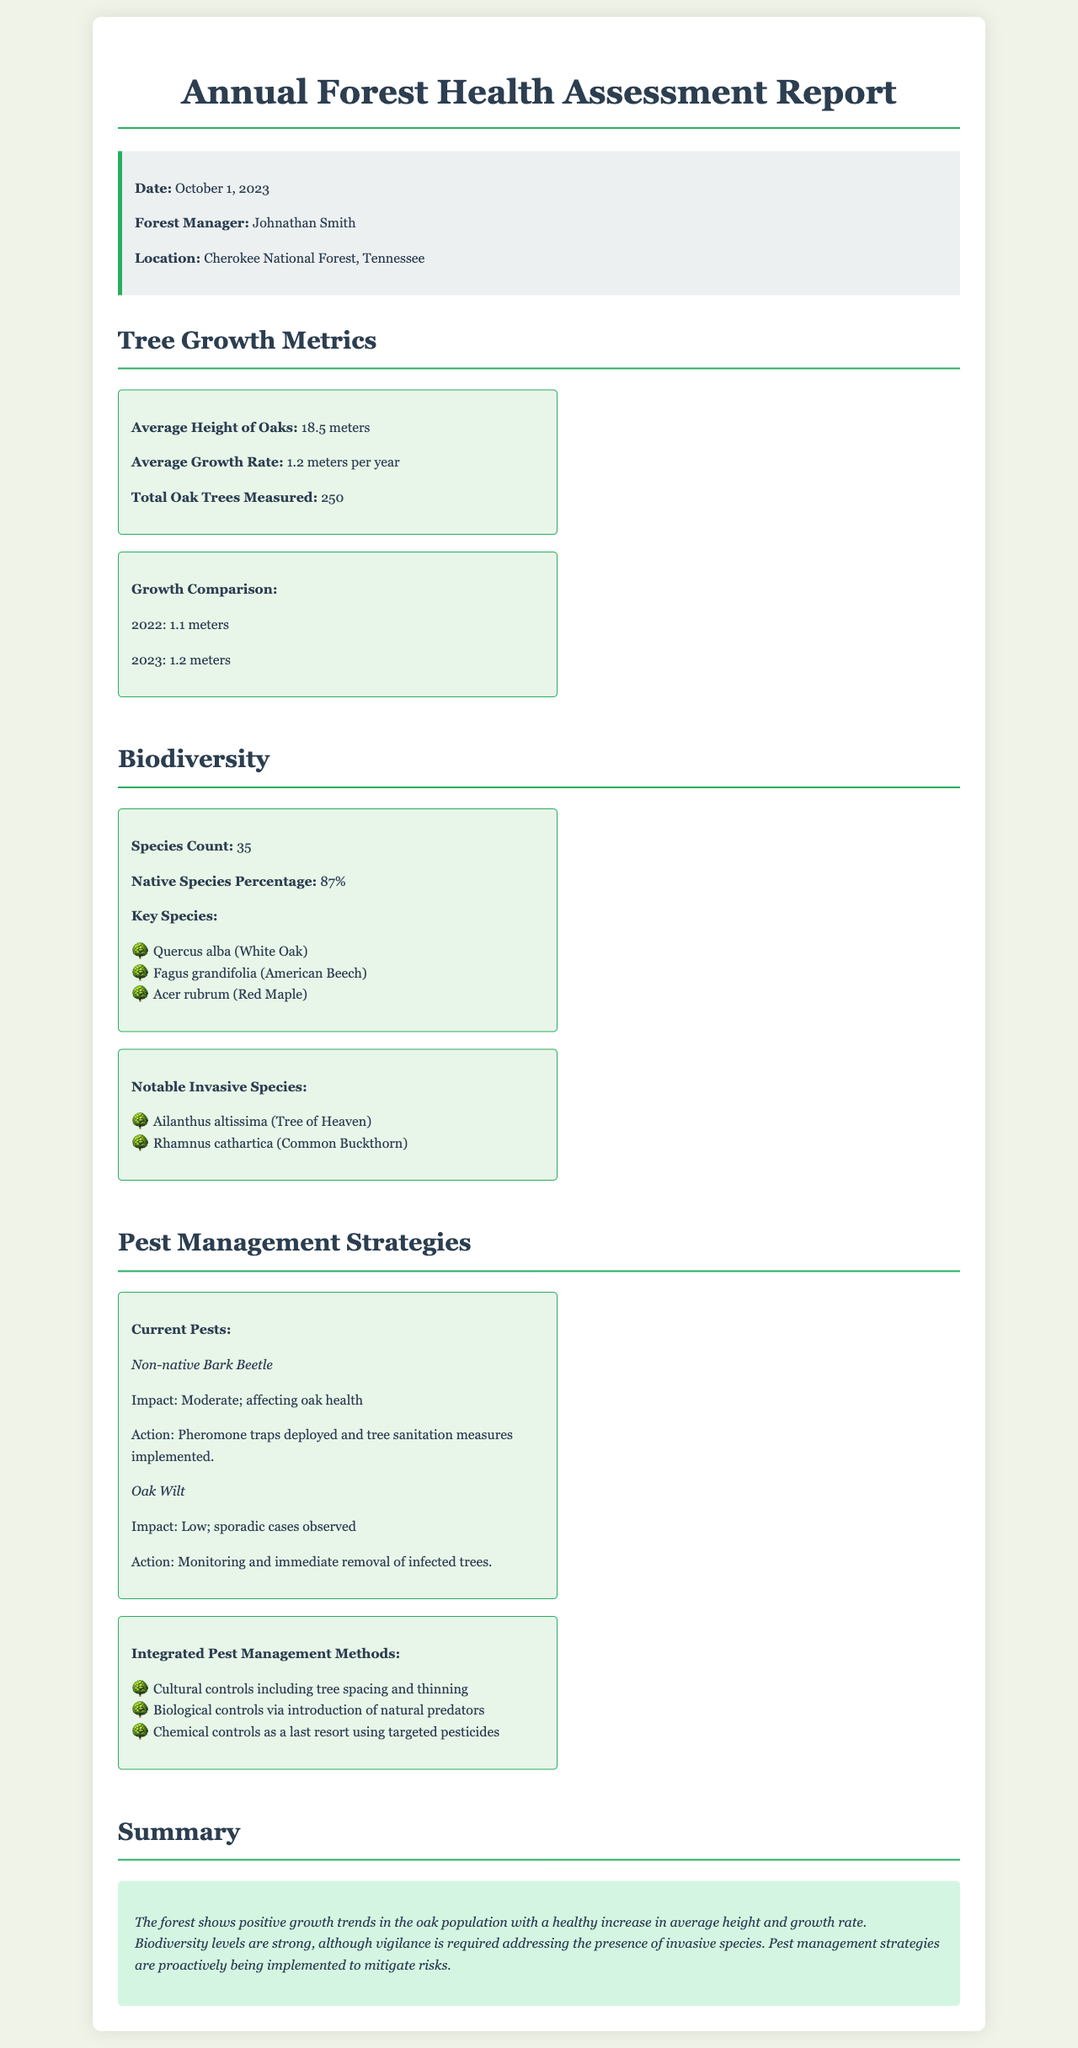What is the average height of oaks? The average height of oaks is explicitly stated in the document under the tree growth metrics section.
Answer: 18.5 meters What is the native species percentage? This detail about biodiversity metrics is provided for understanding the proportion of native species present in the forest.
Answer: 87% What is the total oak trees measured? The document includes this number as part of the tree growth metrics to show the sample size used for analysis.
Answer: 250 What is the impact of the non-native bark beetle? The document provides information about its effects on oak health, which classifies its impact level.
Answer: Moderate What are two key species mentioned in the biodiversity section? The document lists key species that contribute to the biodiversity metrics essential for ecosystem assessment.
Answer: Quercus alba, Fagus grandifolia What is the average growth rate of oaks? The average growth rate is a critical metric listed in the tree growth section of the report.
Answer: 1.2 meters per year What actions are being taken for Oak Wilt? This information elaborates on the pest management strategies in place to deal with specific tree health threats.
Answer: Monitoring and immediate removal of infected trees What are the notable invasive species mentioned? The report specifies invasive species that pose potential threats to native biodiversity and health of the ecosystem.
Answer: Ailanthus altissima, Rhamnus cathartica What is included in integrated pest management methods? This detail provides a summary of the strategies used for effective pest control based on the document's content.
Answer: Cultural controls, Biological controls, Chemical controls 